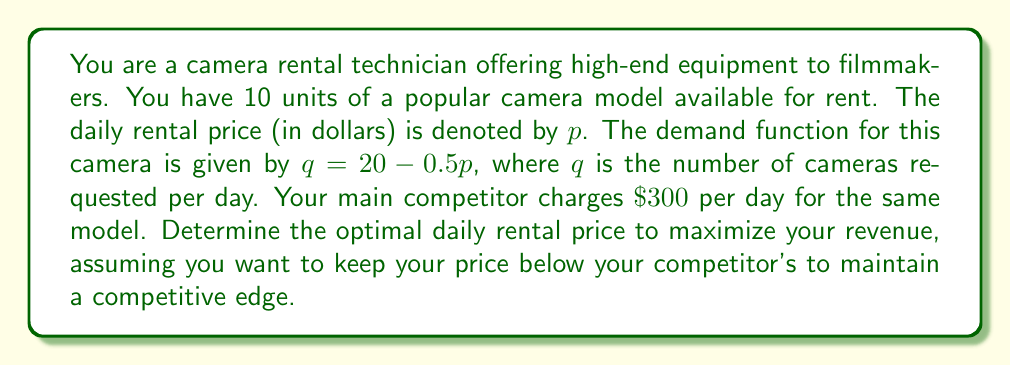Solve this math problem. To solve this problem, we'll follow these steps:

1) The revenue function is given by $R = pq$, where $p$ is the price and $q$ is the quantity demanded.

2) Substitute the demand function into the revenue function:
   $R = p(20 - 0.5p) = 20p - 0.5p^2$

3) To find the maximum revenue, we need to find the derivative of R with respect to p and set it to zero:
   $$\frac{dR}{dp} = 20 - p = 0$$

4) Solve for p:
   $20 - p = 0$
   $p = 20$

5) This gives us the unconstrained optimal price. However, we have two constraints:
   a) We can't rent more than 10 cameras (our inventory constraint)
   b) We want to keep our price below $\$300$ (the competitor's price)

6) Let's check the inventory constraint:
   At $p = 20$, $q = 20 - 0.5(20) = 10$
   This matches our inventory, so this constraint is not binding.

7) Now, let's check the competitive constraint:
   $p = 20 < 300$, so this constraint is also satisfied.

8) Therefore, our optimal price is $\$20$ per day.

9) To calculate the maximum revenue:
   $R = 20(20 - 0.5(20)) = 20(10) = 200$

Thus, the optimal daily rental price is $\$20$, which will result in a maximum daily revenue of $\$200$.
Answer: The optimal daily rental price is $\$20$, resulting in a maximum daily revenue of $\$200$. 